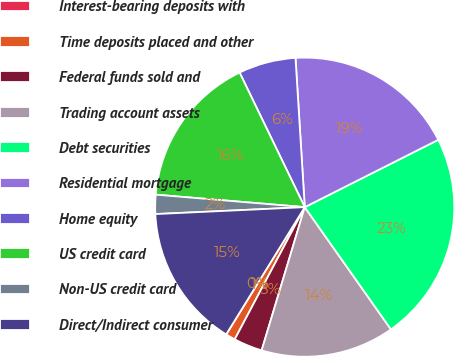Convert chart to OTSL. <chart><loc_0><loc_0><loc_500><loc_500><pie_chart><fcel>Interest-bearing deposits with<fcel>Time deposits placed and other<fcel>Federal funds sold and<fcel>Trading account assets<fcel>Debt securities<fcel>Residential mortgage<fcel>Home equity<fcel>US credit card<fcel>Non-US credit card<fcel>Direct/Indirect consumer<nl><fcel>0.01%<fcel>1.04%<fcel>3.1%<fcel>14.43%<fcel>22.66%<fcel>18.55%<fcel>6.19%<fcel>16.49%<fcel>2.07%<fcel>15.46%<nl></chart> 